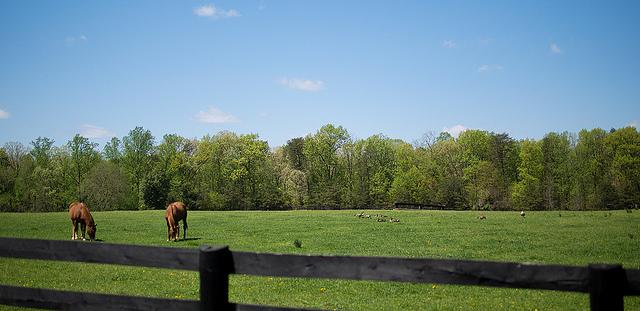What other type of large animal might be found in this environment?

Choices:
A) dog
B) cow
C) elephant
D) tiger cow 